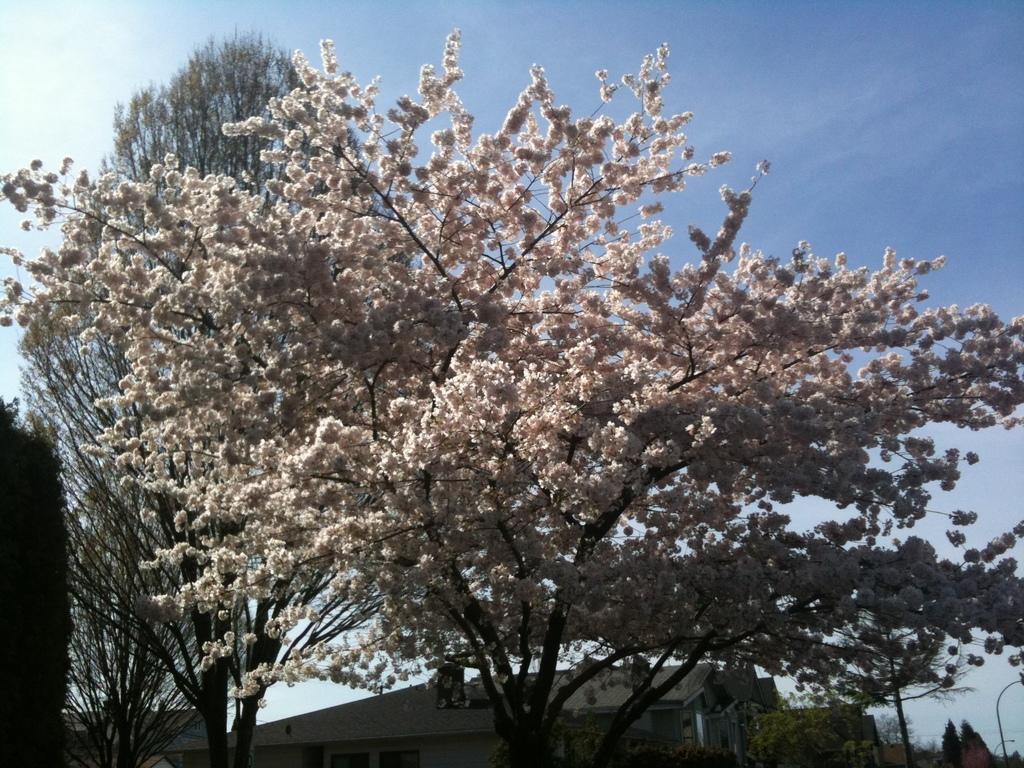Describe this image in one or two sentences. In this image there is a flower plant in the middle. In the background there are buildings. At the top there is sky. There are flowers to the tree. 